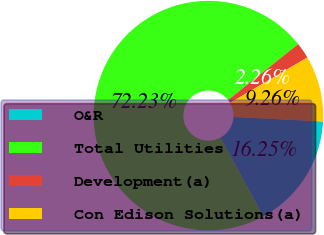Convert chart to OTSL. <chart><loc_0><loc_0><loc_500><loc_500><pie_chart><fcel>O&R<fcel>Total Utilities<fcel>Development(a)<fcel>Con Edison Solutions(a)<nl><fcel>16.25%<fcel>72.23%<fcel>2.26%<fcel>9.26%<nl></chart> 